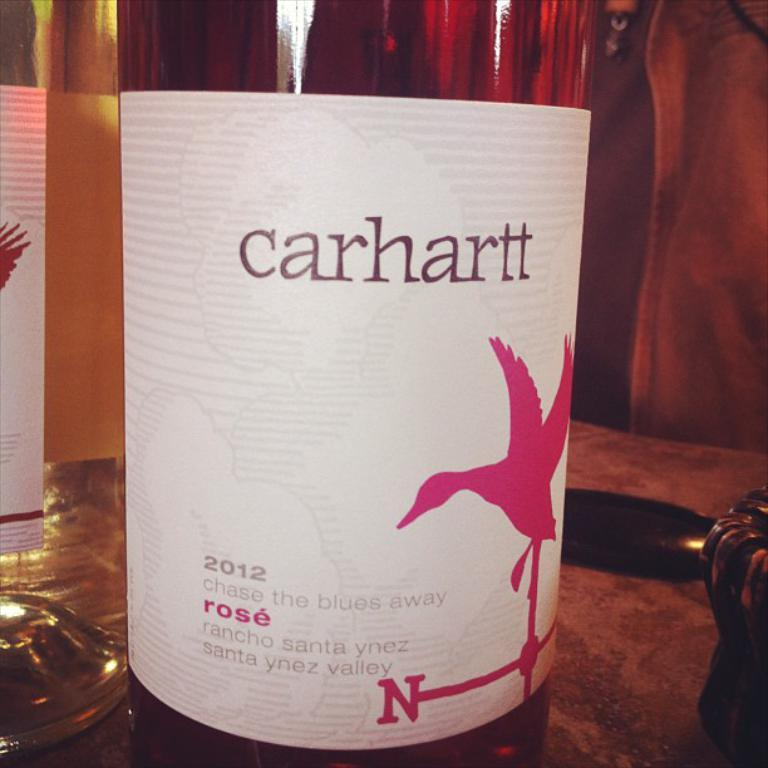What is the main object in the image? There is a wine bottle in the image. Where is the wine bottle located? The wine bottle is on a table. What type of key is used to unlock the train in the image? There is no train or key present in the image; it only features a wine bottle on a table. 